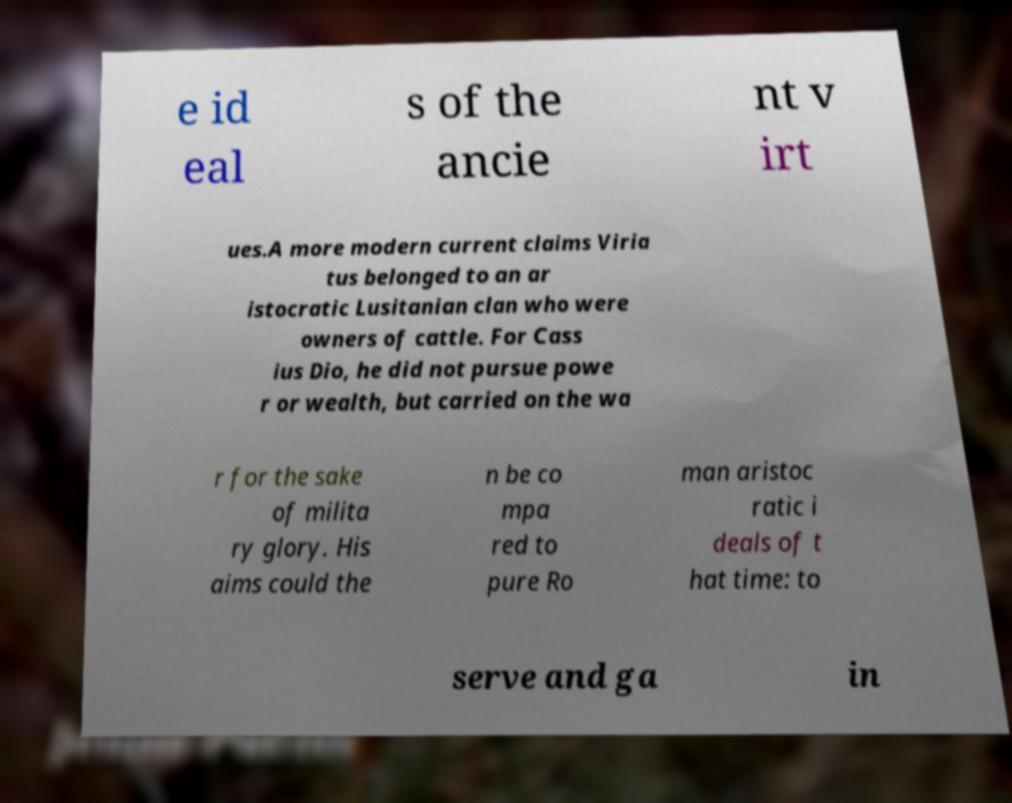Can you read and provide the text displayed in the image?This photo seems to have some interesting text. Can you extract and type it out for me? e id eal s of the ancie nt v irt ues.A more modern current claims Viria tus belonged to an ar istocratic Lusitanian clan who were owners of cattle. For Cass ius Dio, he did not pursue powe r or wealth, but carried on the wa r for the sake of milita ry glory. His aims could the n be co mpa red to pure Ro man aristoc ratic i deals of t hat time: to serve and ga in 